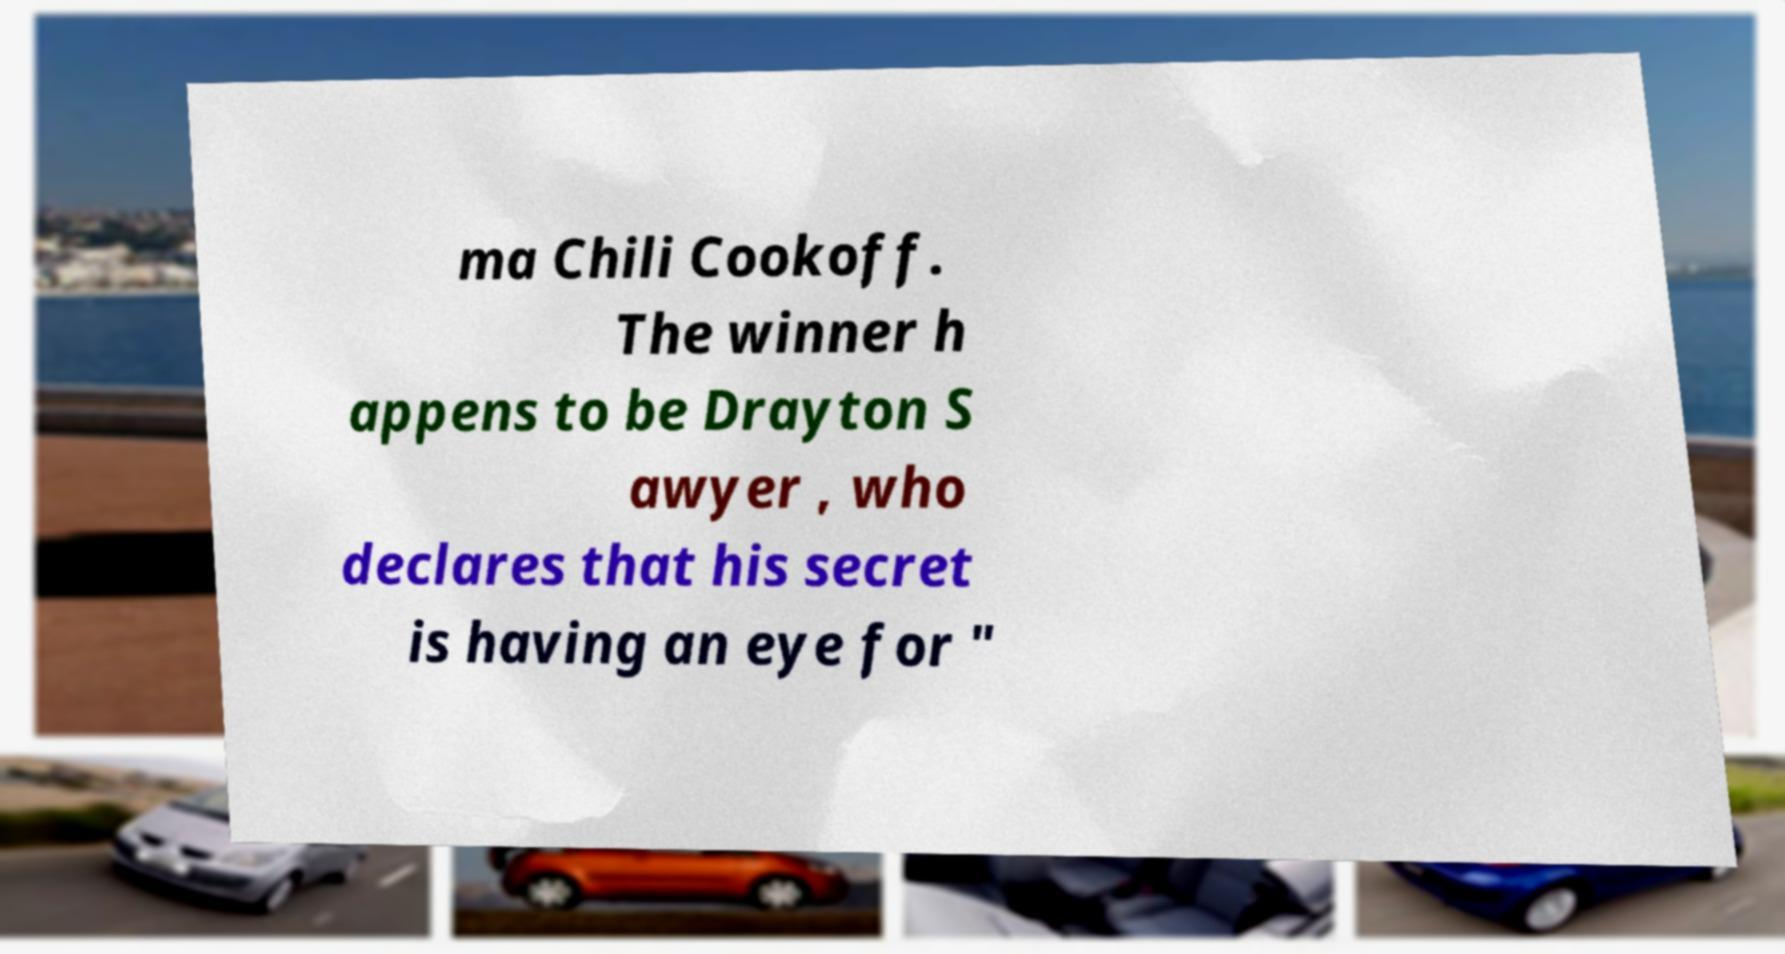For documentation purposes, I need the text within this image transcribed. Could you provide that? ma Chili Cookoff. The winner h appens to be Drayton S awyer , who declares that his secret is having an eye for " 